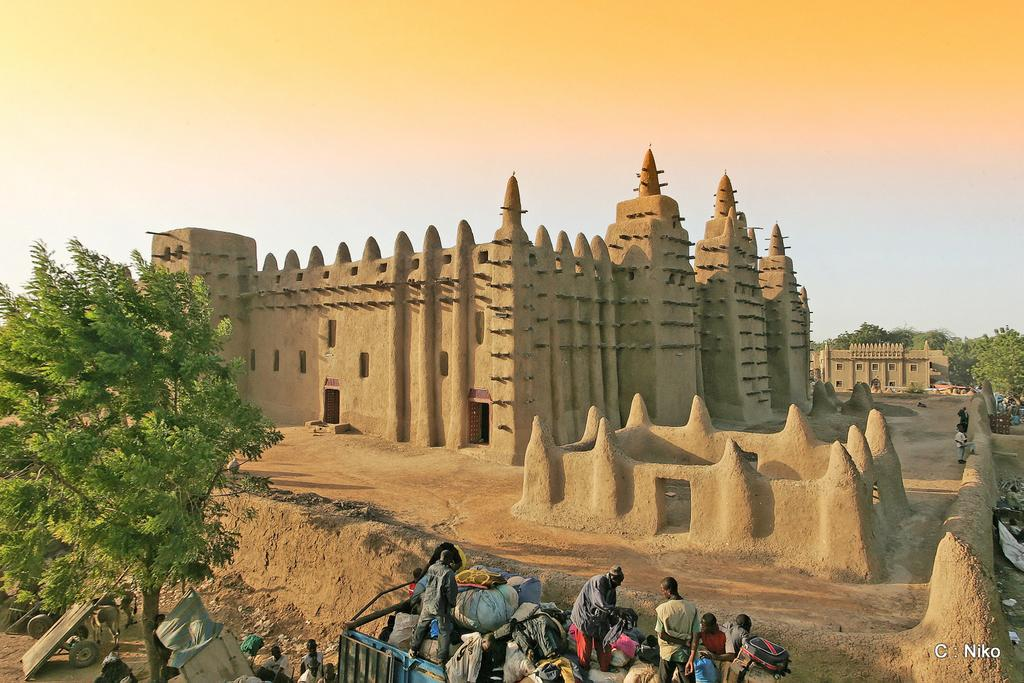How many people are in the image? There are persons in the image, but the exact number is not specified. What else can be seen in the image besides the persons? There are other objects beside the persons. What is located in front of the persons in the image? There is a building in front of the persons. What type of natural scenery is visible in the background of the image? There are trees in the background of the image. Where is the vase located in the image? There is no vase present in the image. What type of wheel can be seen on the persons in the image? There are no wheels visible on the persons in the image. 